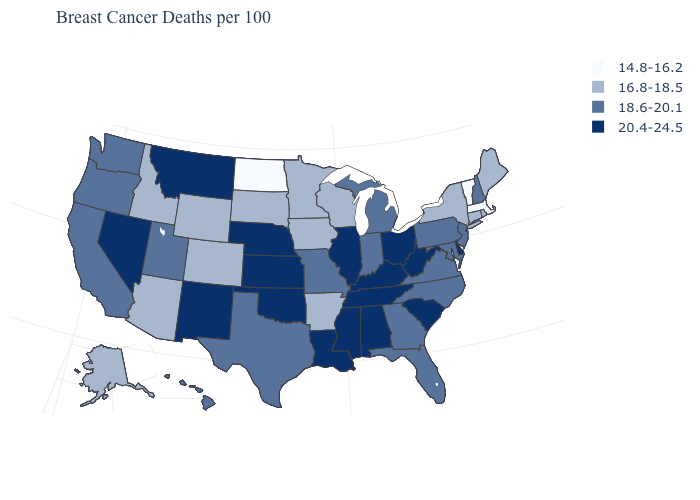Name the states that have a value in the range 16.8-18.5?
Concise answer only. Alaska, Arizona, Arkansas, Colorado, Connecticut, Idaho, Iowa, Maine, Minnesota, New York, Rhode Island, South Dakota, Wisconsin, Wyoming. What is the value of Utah?
Give a very brief answer. 18.6-20.1. Name the states that have a value in the range 16.8-18.5?
Answer briefly. Alaska, Arizona, Arkansas, Colorado, Connecticut, Idaho, Iowa, Maine, Minnesota, New York, Rhode Island, South Dakota, Wisconsin, Wyoming. Does the map have missing data?
Quick response, please. No. What is the value of Washington?
Concise answer only. 18.6-20.1. Name the states that have a value in the range 18.6-20.1?
Short answer required. California, Florida, Georgia, Hawaii, Indiana, Maryland, Michigan, Missouri, New Hampshire, New Jersey, North Carolina, Oregon, Pennsylvania, Texas, Utah, Virginia, Washington. Which states have the lowest value in the Northeast?
Give a very brief answer. Massachusetts, Vermont. What is the lowest value in the Northeast?
Give a very brief answer. 14.8-16.2. What is the value of Iowa?
Answer briefly. 16.8-18.5. What is the value of Missouri?
Quick response, please. 18.6-20.1. What is the value of Oregon?
Quick response, please. 18.6-20.1. Does Maryland have a higher value than Wisconsin?
Be succinct. Yes. What is the value of Illinois?
Keep it brief. 20.4-24.5. Among the states that border Ohio , which have the highest value?
Write a very short answer. Kentucky, West Virginia. Does Arkansas have a higher value than South Carolina?
Keep it brief. No. 